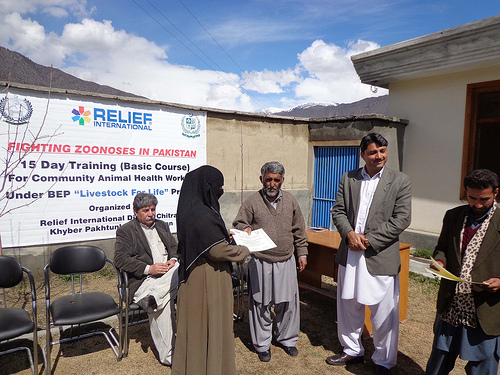<image>
Can you confirm if the man is to the left of the woman? Yes. From this viewpoint, the man is positioned to the left side relative to the woman. 